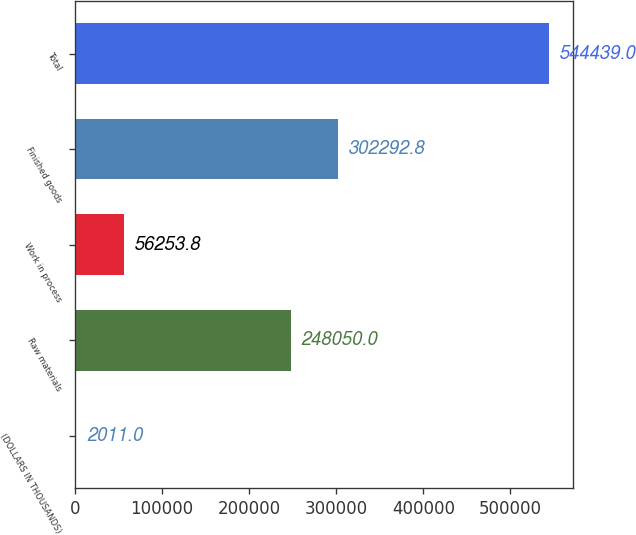<chart> <loc_0><loc_0><loc_500><loc_500><bar_chart><fcel>(DOLLARS IN THOUSANDS)<fcel>Raw materials<fcel>Work in process<fcel>Finished goods<fcel>Total<nl><fcel>2011<fcel>248050<fcel>56253.8<fcel>302293<fcel>544439<nl></chart> 